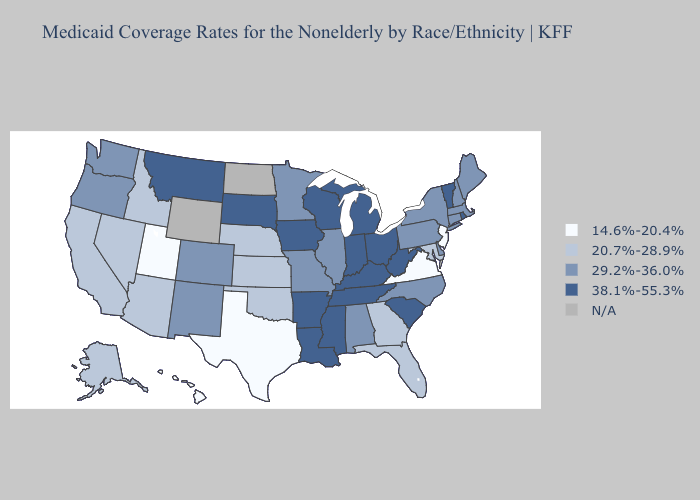Name the states that have a value in the range 29.2%-36.0%?
Answer briefly. Alabama, Colorado, Connecticut, Delaware, Illinois, Maine, Massachusetts, Minnesota, Missouri, New Hampshire, New Mexico, New York, North Carolina, Oregon, Pennsylvania, Washington. What is the highest value in states that border Alabama?
Concise answer only. 38.1%-55.3%. Name the states that have a value in the range 38.1%-55.3%?
Short answer required. Arkansas, Indiana, Iowa, Kentucky, Louisiana, Michigan, Mississippi, Montana, Ohio, Rhode Island, South Carolina, South Dakota, Tennessee, Vermont, West Virginia, Wisconsin. What is the value of Iowa?
Quick response, please. 38.1%-55.3%. Does Minnesota have the lowest value in the USA?
Write a very short answer. No. Name the states that have a value in the range 20.7%-28.9%?
Quick response, please. Alaska, Arizona, California, Florida, Georgia, Idaho, Kansas, Maryland, Nebraska, Nevada, Oklahoma. Which states have the lowest value in the South?
Write a very short answer. Texas, Virginia. What is the value of North Dakota?
Give a very brief answer. N/A. Which states have the highest value in the USA?
Concise answer only. Arkansas, Indiana, Iowa, Kentucky, Louisiana, Michigan, Mississippi, Montana, Ohio, Rhode Island, South Carolina, South Dakota, Tennessee, Vermont, West Virginia, Wisconsin. Which states hav the highest value in the West?
Short answer required. Montana. Does Montana have the highest value in the USA?
Give a very brief answer. Yes. How many symbols are there in the legend?
Quick response, please. 5. Name the states that have a value in the range 29.2%-36.0%?
Concise answer only. Alabama, Colorado, Connecticut, Delaware, Illinois, Maine, Massachusetts, Minnesota, Missouri, New Hampshire, New Mexico, New York, North Carolina, Oregon, Pennsylvania, Washington. What is the highest value in the Northeast ?
Keep it brief. 38.1%-55.3%. 